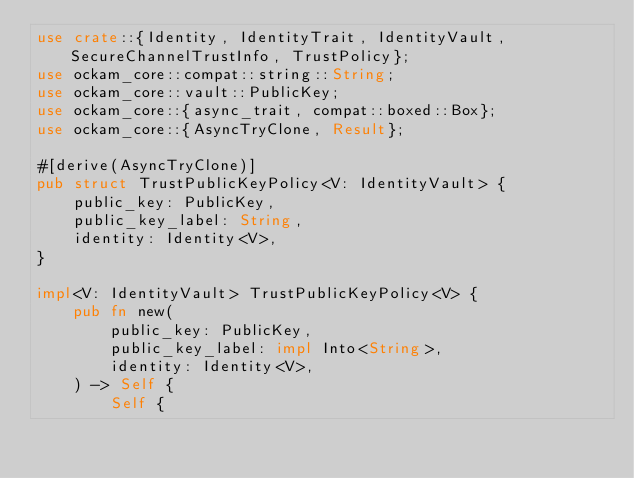<code> <loc_0><loc_0><loc_500><loc_500><_Rust_>use crate::{Identity, IdentityTrait, IdentityVault, SecureChannelTrustInfo, TrustPolicy};
use ockam_core::compat::string::String;
use ockam_core::vault::PublicKey;
use ockam_core::{async_trait, compat::boxed::Box};
use ockam_core::{AsyncTryClone, Result};

#[derive(AsyncTryClone)]
pub struct TrustPublicKeyPolicy<V: IdentityVault> {
    public_key: PublicKey,
    public_key_label: String,
    identity: Identity<V>,
}

impl<V: IdentityVault> TrustPublicKeyPolicy<V> {
    pub fn new(
        public_key: PublicKey,
        public_key_label: impl Into<String>,
        identity: Identity<V>,
    ) -> Self {
        Self {</code> 